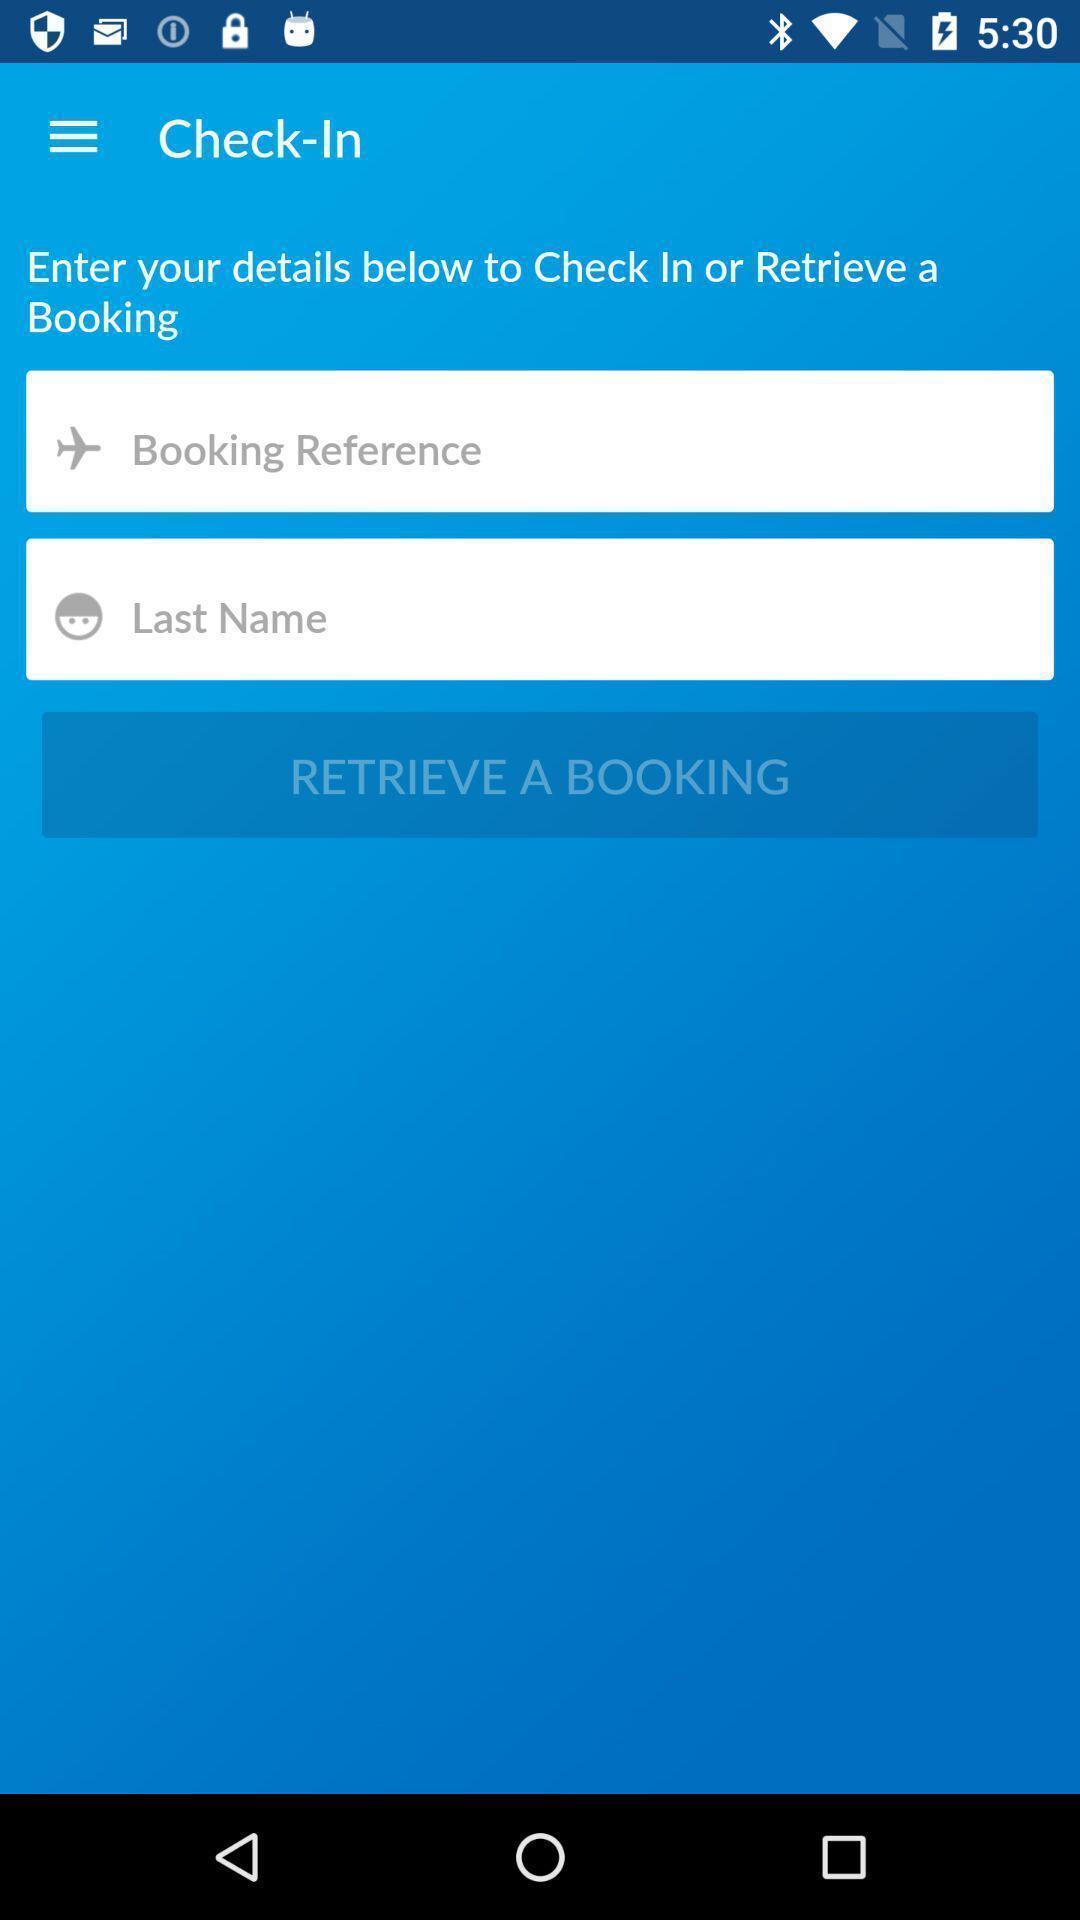Please provide a description for this image. Page with check-in information to book a ticket. 